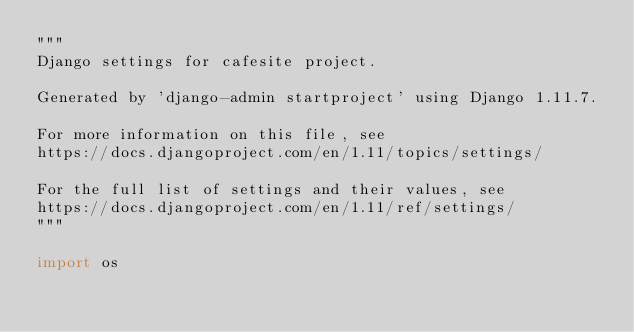Convert code to text. <code><loc_0><loc_0><loc_500><loc_500><_Python_>"""
Django settings for cafesite project.

Generated by 'django-admin startproject' using Django 1.11.7.

For more information on this file, see
https://docs.djangoproject.com/en/1.11/topics/settings/

For the full list of settings and their values, see
https://docs.djangoproject.com/en/1.11/ref/settings/
"""

import os
</code> 